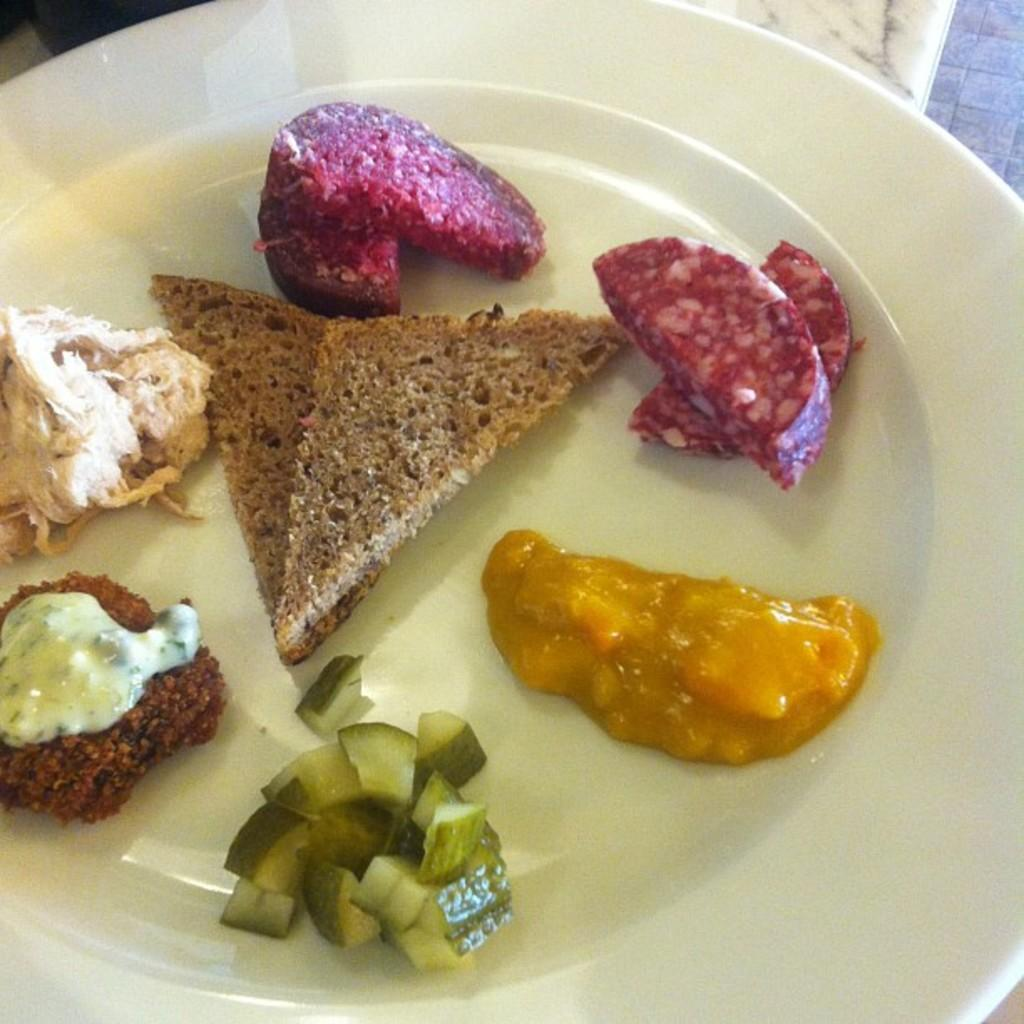What type of food is present on the plate in the image? There are bread slices, cucumber, and some creams on the plate. Can you describe the different items on the plate? The plate contains bread slices, cucumber, and creams. What might be used to spread on the bread slices? The creams on the plate might be used to spread on the bread slices. Where is the shelf located in the image? There is no shelf present in the image. What type of yam is being used to make the bread slices? There is no yam present in the image, and the bread slices are not made from yam. 